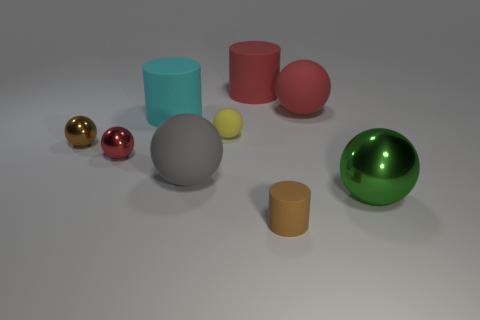What number of matte balls are to the left of the small matte sphere and on the right side of the red matte cylinder?
Your answer should be very brief. 0. The tiny matte cylinder is what color?
Provide a short and direct response. Brown. There is a small brown object that is the same shape as the cyan object; what is it made of?
Offer a very short reply. Rubber. Is there anything else that has the same material as the large gray thing?
Your answer should be very brief. Yes. Is the color of the big metallic object the same as the small cylinder?
Keep it short and to the point. No. There is a red rubber thing that is to the left of the small matte thing in front of the big gray ball; what shape is it?
Give a very brief answer. Cylinder. What is the shape of the small yellow thing that is made of the same material as the big gray object?
Make the answer very short. Sphere. What number of other things are there of the same shape as the big green metallic thing?
Your response must be concise. 5. Is the size of the ball that is behind the yellow rubber object the same as the large green shiny thing?
Ensure brevity in your answer.  Yes. Are there more green metallic things left of the tiny brown sphere than big purple spheres?
Give a very brief answer. No. 